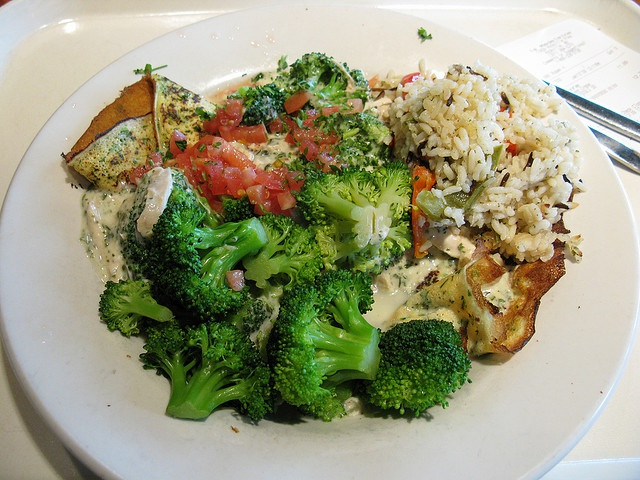Describe the objects in this image and their specific colors. I can see broccoli in maroon, black, darkgreen, and green tones, broccoli in maroon, black, darkgreen, and olive tones, and knife in maroon, gray, darkgray, lightgray, and blue tones in this image. 